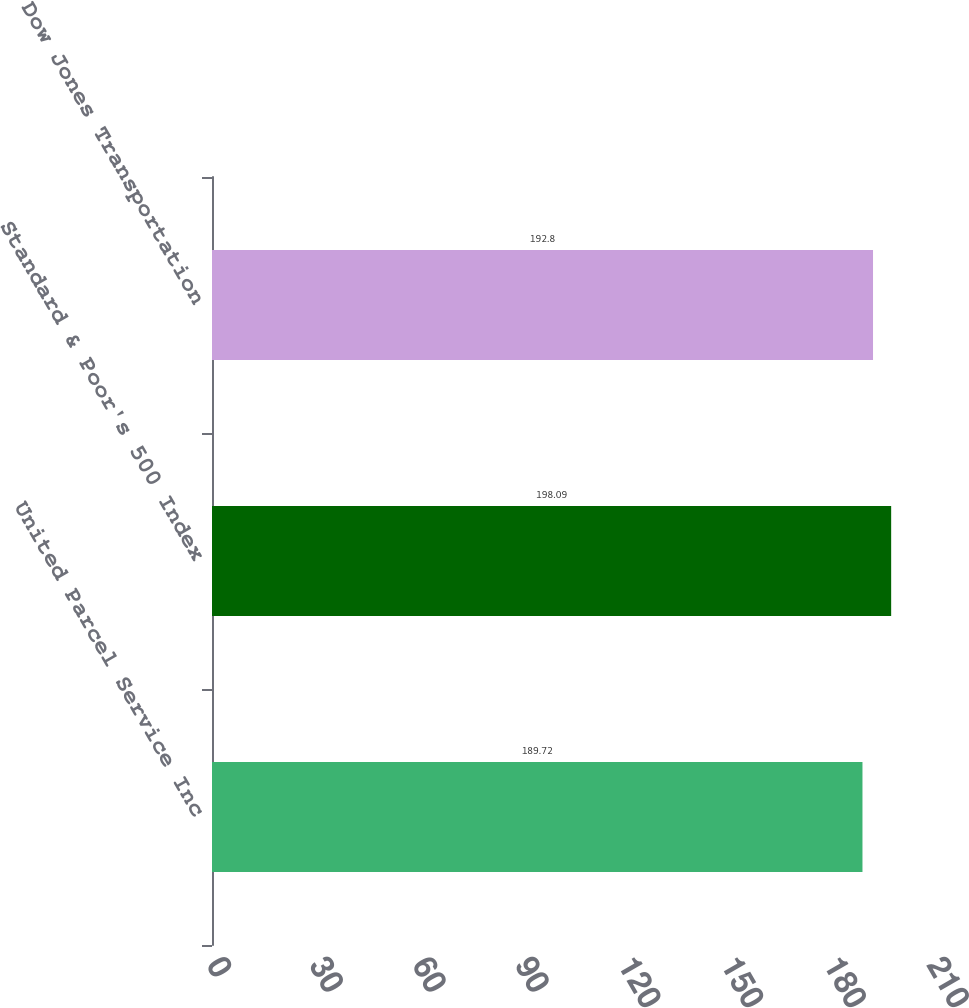Convert chart to OTSL. <chart><loc_0><loc_0><loc_500><loc_500><bar_chart><fcel>United Parcel Service Inc<fcel>Standard & Poor's 500 Index<fcel>Dow Jones Transportation<nl><fcel>189.72<fcel>198.09<fcel>192.8<nl></chart> 